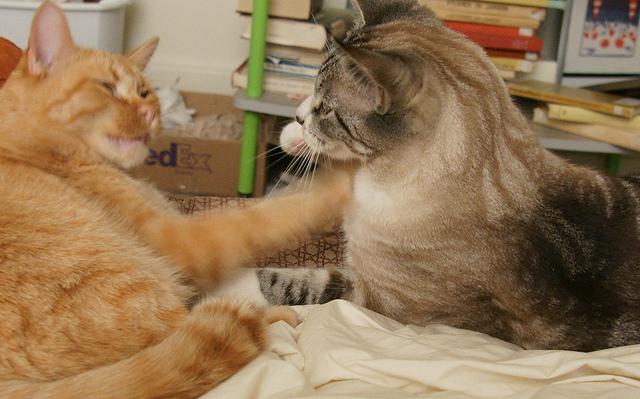What is written on the box in the background?
Give a very brief answer. Fedex. Where is this taken?
Give a very brief answer. Inside. What color are the cats?
Short answer required. Orange and gray. 